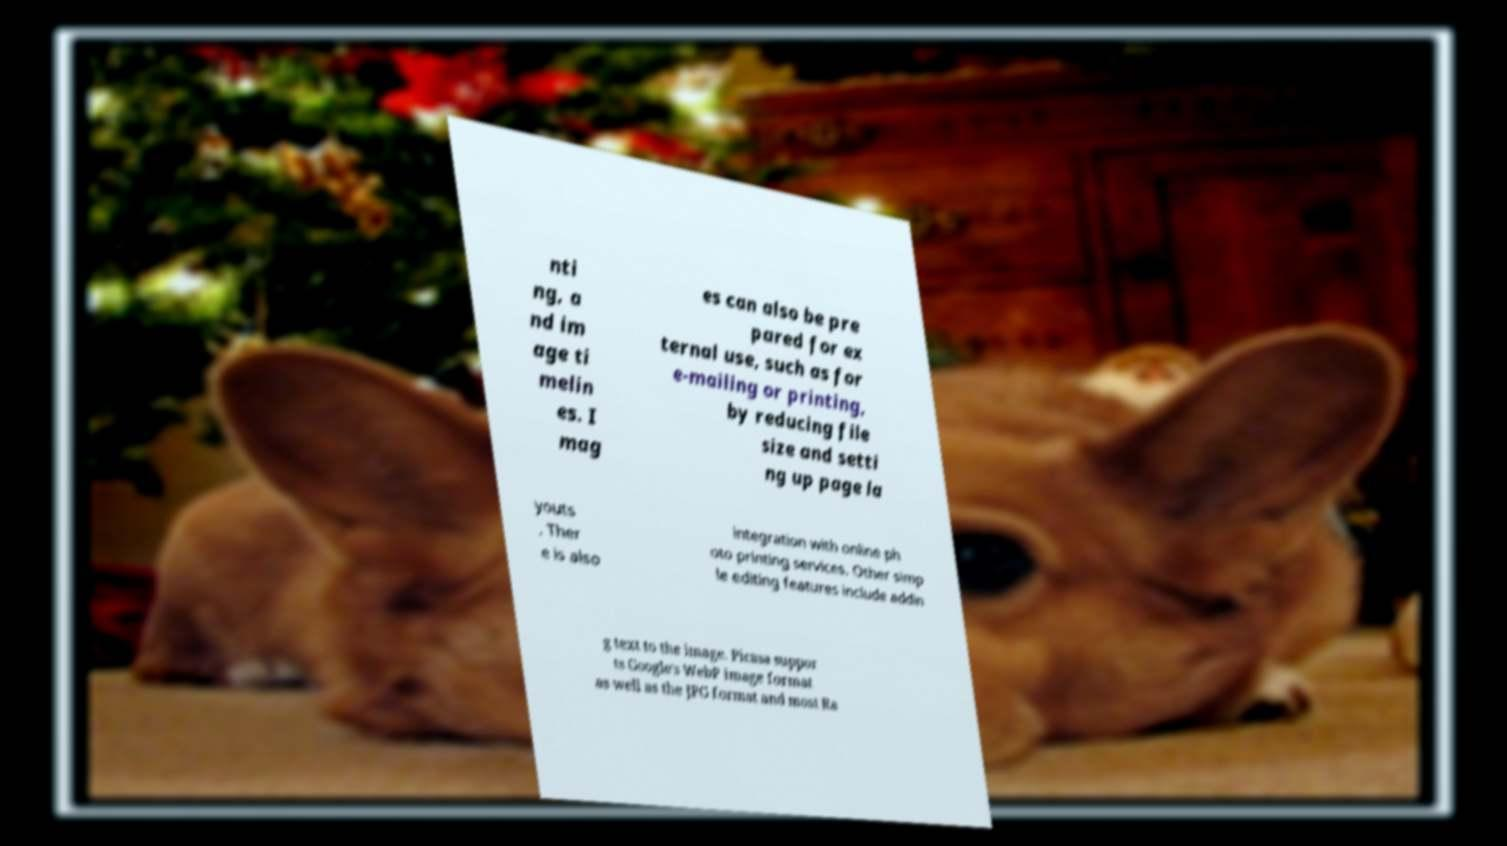There's text embedded in this image that I need extracted. Can you transcribe it verbatim? nti ng, a nd im age ti melin es. I mag es can also be pre pared for ex ternal use, such as for e-mailing or printing, by reducing file size and setti ng up page la youts . Ther e is also integration with online ph oto printing services. Other simp le editing features include addin g text to the image. Picasa suppor ts Google's WebP image format as well as the JPG format and most Ra 